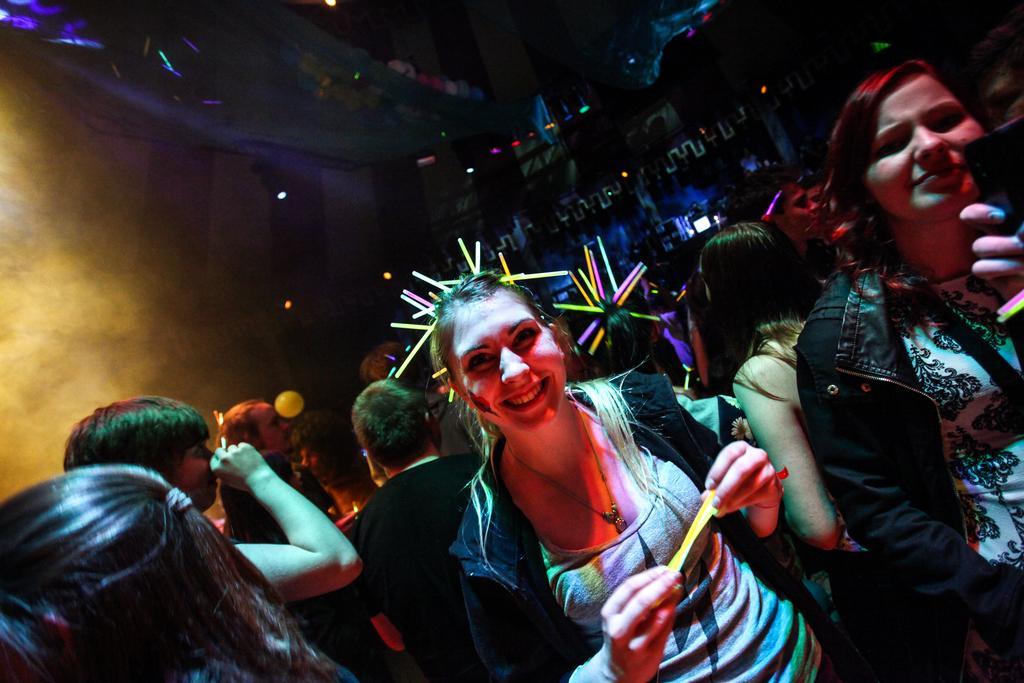Please provide a concise description of this image. In the image few people are standing and holding something. Behind them there is fog and lights. 